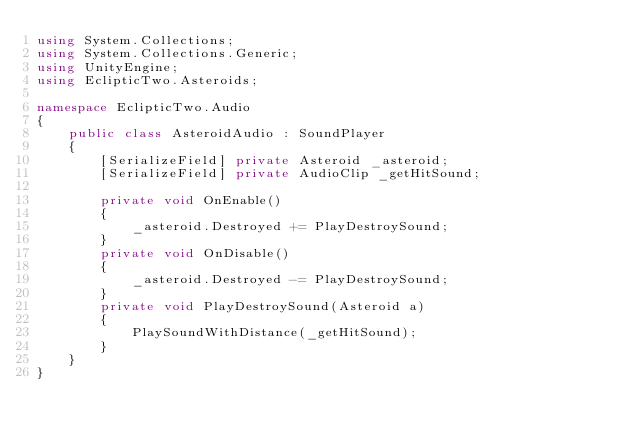<code> <loc_0><loc_0><loc_500><loc_500><_C#_>using System.Collections;
using System.Collections.Generic;
using UnityEngine;
using EclipticTwo.Asteroids;

namespace EclipticTwo.Audio
{
    public class AsteroidAudio : SoundPlayer
    {
        [SerializeField] private Asteroid _asteroid;
        [SerializeField] private AudioClip _getHitSound;

        private void OnEnable()
        {
            _asteroid.Destroyed += PlayDestroySound;
        }
        private void OnDisable()
        {
            _asteroid.Destroyed -= PlayDestroySound;
        }
        private void PlayDestroySound(Asteroid a)
        {
            PlaySoundWithDistance(_getHitSound);
        }
    }
}</code> 